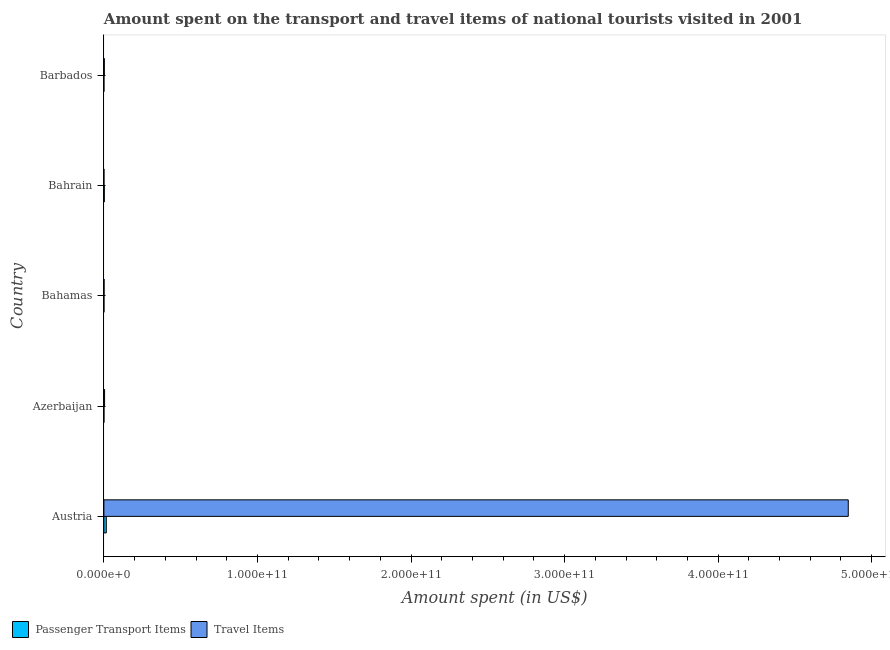How many different coloured bars are there?
Give a very brief answer. 2. How many groups of bars are there?
Ensure brevity in your answer.  5. What is the label of the 2nd group of bars from the top?
Give a very brief answer. Bahrain. In how many cases, is the number of bars for a given country not equal to the number of legend labels?
Give a very brief answer. 0. What is the amount spent on passenger transport items in Barbados?
Provide a short and direct response. 9.00e+06. Across all countries, what is the maximum amount spent on passenger transport items?
Offer a very short reply. 1.56e+09. Across all countries, what is the minimum amount spent in travel items?
Provide a short and direct response. 2.20e+07. In which country was the amount spent in travel items minimum?
Give a very brief answer. Bahrain. What is the total amount spent on passenger transport items in the graph?
Your response must be concise. 1.86e+09. What is the difference between the amount spent on passenger transport items in Azerbaijan and that in Bahrain?
Offer a terse response. -2.42e+08. What is the difference between the amount spent in travel items in Austria and the amount spent on passenger transport items in Barbados?
Ensure brevity in your answer.  4.85e+11. What is the average amount spent on passenger transport items per country?
Your answer should be compact. 3.72e+08. What is the difference between the amount spent in travel items and amount spent on passenger transport items in Azerbaijan?
Offer a very short reply. 4.32e+08. In how many countries, is the amount spent on passenger transport items greater than 20000000000 US$?
Make the answer very short. 0. What is the ratio of the amount spent in travel items in Austria to that in Azerbaijan?
Keep it short and to the point. 1086.87. Is the amount spent in travel items in Austria less than that in Barbados?
Provide a short and direct response. No. Is the difference between the amount spent in travel items in Austria and Bahrain greater than the difference between the amount spent on passenger transport items in Austria and Bahrain?
Your response must be concise. Yes. What is the difference between the highest and the second highest amount spent on passenger transport items?
Provide a succinct answer. 1.31e+09. What is the difference between the highest and the lowest amount spent in travel items?
Make the answer very short. 4.85e+11. In how many countries, is the amount spent on passenger transport items greater than the average amount spent on passenger transport items taken over all countries?
Offer a terse response. 1. Is the sum of the amount spent on passenger transport items in Austria and Bahamas greater than the maximum amount spent in travel items across all countries?
Your answer should be compact. No. What does the 1st bar from the top in Austria represents?
Provide a short and direct response. Travel Items. What does the 2nd bar from the bottom in Austria represents?
Make the answer very short. Travel Items. How many bars are there?
Your response must be concise. 10. Are all the bars in the graph horizontal?
Your response must be concise. Yes. What is the difference between two consecutive major ticks on the X-axis?
Your response must be concise. 1.00e+11. Does the graph contain any zero values?
Your answer should be compact. No. Does the graph contain grids?
Make the answer very short. No. How are the legend labels stacked?
Give a very brief answer. Horizontal. What is the title of the graph?
Provide a short and direct response. Amount spent on the transport and travel items of national tourists visited in 2001. What is the label or title of the X-axis?
Offer a very short reply. Amount spent (in US$). What is the label or title of the Y-axis?
Give a very brief answer. Country. What is the Amount spent (in US$) of Passenger Transport Items in Austria?
Your answer should be very brief. 1.56e+09. What is the Amount spent (in US$) in Travel Items in Austria?
Make the answer very short. 4.85e+11. What is the Amount spent (in US$) in Passenger Transport Items in Azerbaijan?
Provide a short and direct response. 1.40e+07. What is the Amount spent (in US$) of Travel Items in Azerbaijan?
Ensure brevity in your answer.  4.46e+08. What is the Amount spent (in US$) of Passenger Transport Items in Bahamas?
Give a very brief answer. 1.70e+07. What is the Amount spent (in US$) of Travel Items in Bahamas?
Provide a succinct answer. 1.00e+08. What is the Amount spent (in US$) in Passenger Transport Items in Bahrain?
Provide a succinct answer. 2.56e+08. What is the Amount spent (in US$) of Travel Items in Bahrain?
Keep it short and to the point. 2.20e+07. What is the Amount spent (in US$) of Passenger Transport Items in Barbados?
Make the answer very short. 9.00e+06. What is the Amount spent (in US$) of Travel Items in Barbados?
Keep it short and to the point. 2.72e+08. Across all countries, what is the maximum Amount spent (in US$) of Passenger Transport Items?
Give a very brief answer. 1.56e+09. Across all countries, what is the maximum Amount spent (in US$) in Travel Items?
Give a very brief answer. 4.85e+11. Across all countries, what is the minimum Amount spent (in US$) of Passenger Transport Items?
Offer a terse response. 9.00e+06. Across all countries, what is the minimum Amount spent (in US$) in Travel Items?
Keep it short and to the point. 2.20e+07. What is the total Amount spent (in US$) in Passenger Transport Items in the graph?
Offer a terse response. 1.86e+09. What is the total Amount spent (in US$) in Travel Items in the graph?
Your answer should be very brief. 4.86e+11. What is the difference between the Amount spent (in US$) in Passenger Transport Items in Austria and that in Azerbaijan?
Your response must be concise. 1.55e+09. What is the difference between the Amount spent (in US$) of Travel Items in Austria and that in Azerbaijan?
Offer a very short reply. 4.84e+11. What is the difference between the Amount spent (in US$) in Passenger Transport Items in Austria and that in Bahamas?
Make the answer very short. 1.55e+09. What is the difference between the Amount spent (in US$) of Travel Items in Austria and that in Bahamas?
Ensure brevity in your answer.  4.85e+11. What is the difference between the Amount spent (in US$) of Passenger Transport Items in Austria and that in Bahrain?
Offer a terse response. 1.31e+09. What is the difference between the Amount spent (in US$) of Travel Items in Austria and that in Bahrain?
Make the answer very short. 4.85e+11. What is the difference between the Amount spent (in US$) in Passenger Transport Items in Austria and that in Barbados?
Keep it short and to the point. 1.55e+09. What is the difference between the Amount spent (in US$) in Travel Items in Austria and that in Barbados?
Offer a very short reply. 4.84e+11. What is the difference between the Amount spent (in US$) in Travel Items in Azerbaijan and that in Bahamas?
Offer a very short reply. 3.46e+08. What is the difference between the Amount spent (in US$) in Passenger Transport Items in Azerbaijan and that in Bahrain?
Your answer should be very brief. -2.42e+08. What is the difference between the Amount spent (in US$) of Travel Items in Azerbaijan and that in Bahrain?
Make the answer very short. 4.24e+08. What is the difference between the Amount spent (in US$) in Passenger Transport Items in Azerbaijan and that in Barbados?
Give a very brief answer. 5.00e+06. What is the difference between the Amount spent (in US$) in Travel Items in Azerbaijan and that in Barbados?
Provide a succinct answer. 1.74e+08. What is the difference between the Amount spent (in US$) in Passenger Transport Items in Bahamas and that in Bahrain?
Provide a short and direct response. -2.39e+08. What is the difference between the Amount spent (in US$) of Travel Items in Bahamas and that in Bahrain?
Your answer should be very brief. 7.80e+07. What is the difference between the Amount spent (in US$) of Travel Items in Bahamas and that in Barbados?
Provide a short and direct response. -1.72e+08. What is the difference between the Amount spent (in US$) of Passenger Transport Items in Bahrain and that in Barbados?
Offer a very short reply. 2.47e+08. What is the difference between the Amount spent (in US$) in Travel Items in Bahrain and that in Barbados?
Your response must be concise. -2.50e+08. What is the difference between the Amount spent (in US$) of Passenger Transport Items in Austria and the Amount spent (in US$) of Travel Items in Azerbaijan?
Keep it short and to the point. 1.12e+09. What is the difference between the Amount spent (in US$) of Passenger Transport Items in Austria and the Amount spent (in US$) of Travel Items in Bahamas?
Your answer should be compact. 1.46e+09. What is the difference between the Amount spent (in US$) in Passenger Transport Items in Austria and the Amount spent (in US$) in Travel Items in Bahrain?
Your answer should be compact. 1.54e+09. What is the difference between the Amount spent (in US$) of Passenger Transport Items in Austria and the Amount spent (in US$) of Travel Items in Barbados?
Provide a short and direct response. 1.29e+09. What is the difference between the Amount spent (in US$) of Passenger Transport Items in Azerbaijan and the Amount spent (in US$) of Travel Items in Bahamas?
Provide a succinct answer. -8.60e+07. What is the difference between the Amount spent (in US$) in Passenger Transport Items in Azerbaijan and the Amount spent (in US$) in Travel Items in Bahrain?
Your answer should be very brief. -8.00e+06. What is the difference between the Amount spent (in US$) in Passenger Transport Items in Azerbaijan and the Amount spent (in US$) in Travel Items in Barbados?
Your response must be concise. -2.58e+08. What is the difference between the Amount spent (in US$) of Passenger Transport Items in Bahamas and the Amount spent (in US$) of Travel Items in Bahrain?
Your response must be concise. -5.00e+06. What is the difference between the Amount spent (in US$) in Passenger Transport Items in Bahamas and the Amount spent (in US$) in Travel Items in Barbados?
Offer a very short reply. -2.55e+08. What is the difference between the Amount spent (in US$) in Passenger Transport Items in Bahrain and the Amount spent (in US$) in Travel Items in Barbados?
Your response must be concise. -1.60e+07. What is the average Amount spent (in US$) in Passenger Transport Items per country?
Your answer should be very brief. 3.72e+08. What is the average Amount spent (in US$) in Travel Items per country?
Provide a short and direct response. 9.71e+1. What is the difference between the Amount spent (in US$) of Passenger Transport Items and Amount spent (in US$) of Travel Items in Austria?
Keep it short and to the point. -4.83e+11. What is the difference between the Amount spent (in US$) of Passenger Transport Items and Amount spent (in US$) of Travel Items in Azerbaijan?
Your answer should be very brief. -4.32e+08. What is the difference between the Amount spent (in US$) of Passenger Transport Items and Amount spent (in US$) of Travel Items in Bahamas?
Make the answer very short. -8.30e+07. What is the difference between the Amount spent (in US$) in Passenger Transport Items and Amount spent (in US$) in Travel Items in Bahrain?
Make the answer very short. 2.34e+08. What is the difference between the Amount spent (in US$) in Passenger Transport Items and Amount spent (in US$) in Travel Items in Barbados?
Ensure brevity in your answer.  -2.63e+08. What is the ratio of the Amount spent (in US$) of Passenger Transport Items in Austria to that in Azerbaijan?
Keep it short and to the point. 111.64. What is the ratio of the Amount spent (in US$) of Travel Items in Austria to that in Azerbaijan?
Make the answer very short. 1086.87. What is the ratio of the Amount spent (in US$) in Passenger Transport Items in Austria to that in Bahamas?
Provide a succinct answer. 91.94. What is the ratio of the Amount spent (in US$) in Travel Items in Austria to that in Bahamas?
Your answer should be compact. 4847.43. What is the ratio of the Amount spent (in US$) of Passenger Transport Items in Austria to that in Bahrain?
Provide a succinct answer. 6.11. What is the ratio of the Amount spent (in US$) of Travel Items in Austria to that in Bahrain?
Offer a terse response. 2.20e+04. What is the ratio of the Amount spent (in US$) of Passenger Transport Items in Austria to that in Barbados?
Provide a short and direct response. 173.67. What is the ratio of the Amount spent (in US$) of Travel Items in Austria to that in Barbados?
Your answer should be very brief. 1782.14. What is the ratio of the Amount spent (in US$) of Passenger Transport Items in Azerbaijan to that in Bahamas?
Ensure brevity in your answer.  0.82. What is the ratio of the Amount spent (in US$) in Travel Items in Azerbaijan to that in Bahamas?
Offer a very short reply. 4.46. What is the ratio of the Amount spent (in US$) of Passenger Transport Items in Azerbaijan to that in Bahrain?
Provide a succinct answer. 0.05. What is the ratio of the Amount spent (in US$) in Travel Items in Azerbaijan to that in Bahrain?
Your answer should be compact. 20.27. What is the ratio of the Amount spent (in US$) in Passenger Transport Items in Azerbaijan to that in Barbados?
Ensure brevity in your answer.  1.56. What is the ratio of the Amount spent (in US$) in Travel Items in Azerbaijan to that in Barbados?
Provide a succinct answer. 1.64. What is the ratio of the Amount spent (in US$) in Passenger Transport Items in Bahamas to that in Bahrain?
Keep it short and to the point. 0.07. What is the ratio of the Amount spent (in US$) in Travel Items in Bahamas to that in Bahrain?
Provide a succinct answer. 4.55. What is the ratio of the Amount spent (in US$) of Passenger Transport Items in Bahamas to that in Barbados?
Make the answer very short. 1.89. What is the ratio of the Amount spent (in US$) in Travel Items in Bahamas to that in Barbados?
Offer a very short reply. 0.37. What is the ratio of the Amount spent (in US$) in Passenger Transport Items in Bahrain to that in Barbados?
Ensure brevity in your answer.  28.44. What is the ratio of the Amount spent (in US$) in Travel Items in Bahrain to that in Barbados?
Provide a succinct answer. 0.08. What is the difference between the highest and the second highest Amount spent (in US$) of Passenger Transport Items?
Keep it short and to the point. 1.31e+09. What is the difference between the highest and the second highest Amount spent (in US$) in Travel Items?
Provide a succinct answer. 4.84e+11. What is the difference between the highest and the lowest Amount spent (in US$) of Passenger Transport Items?
Your response must be concise. 1.55e+09. What is the difference between the highest and the lowest Amount spent (in US$) in Travel Items?
Ensure brevity in your answer.  4.85e+11. 